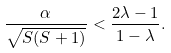Convert formula to latex. <formula><loc_0><loc_0><loc_500><loc_500>\frac { \alpha } { \sqrt { S ( S + 1 ) } } < \frac { 2 \lambda - 1 } { 1 - \lambda } .</formula> 